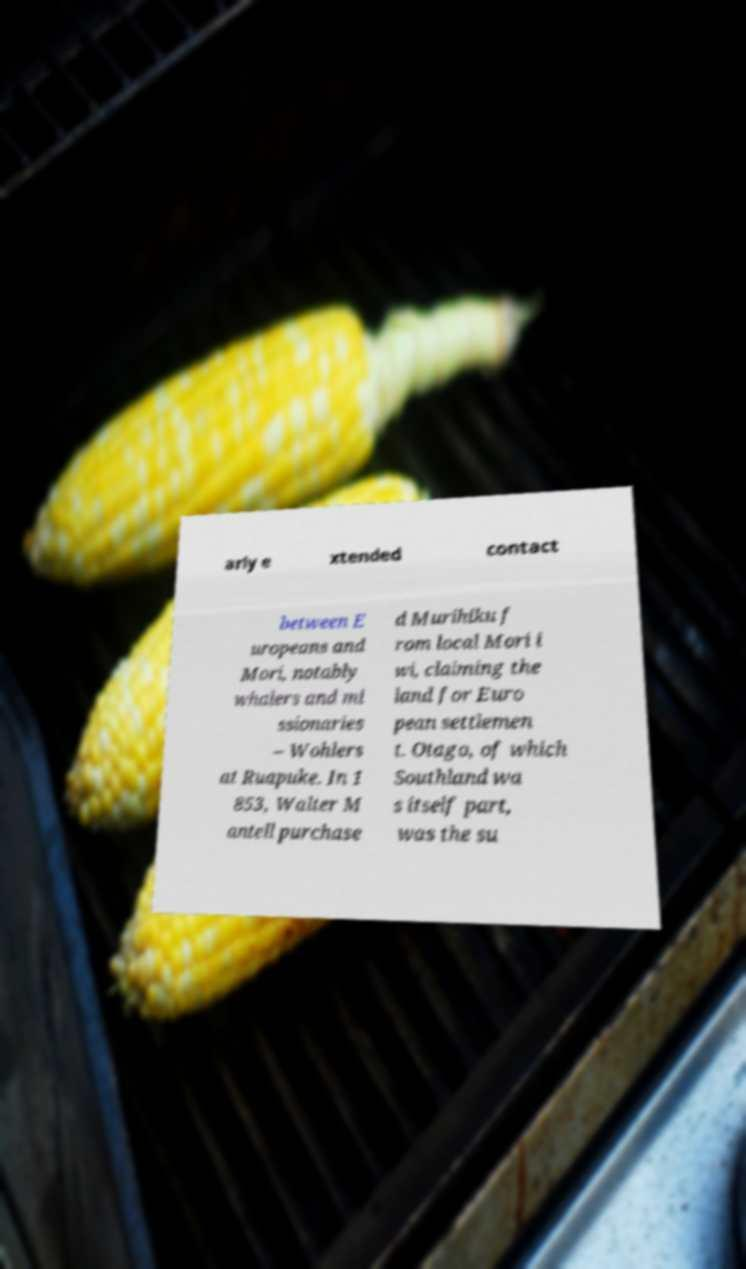I need the written content from this picture converted into text. Can you do that? arly e xtended contact between E uropeans and Mori, notably whalers and mi ssionaries – Wohlers at Ruapuke. In 1 853, Walter M antell purchase d Murihiku f rom local Mori i wi, claiming the land for Euro pean settlemen t. Otago, of which Southland wa s itself part, was the su 